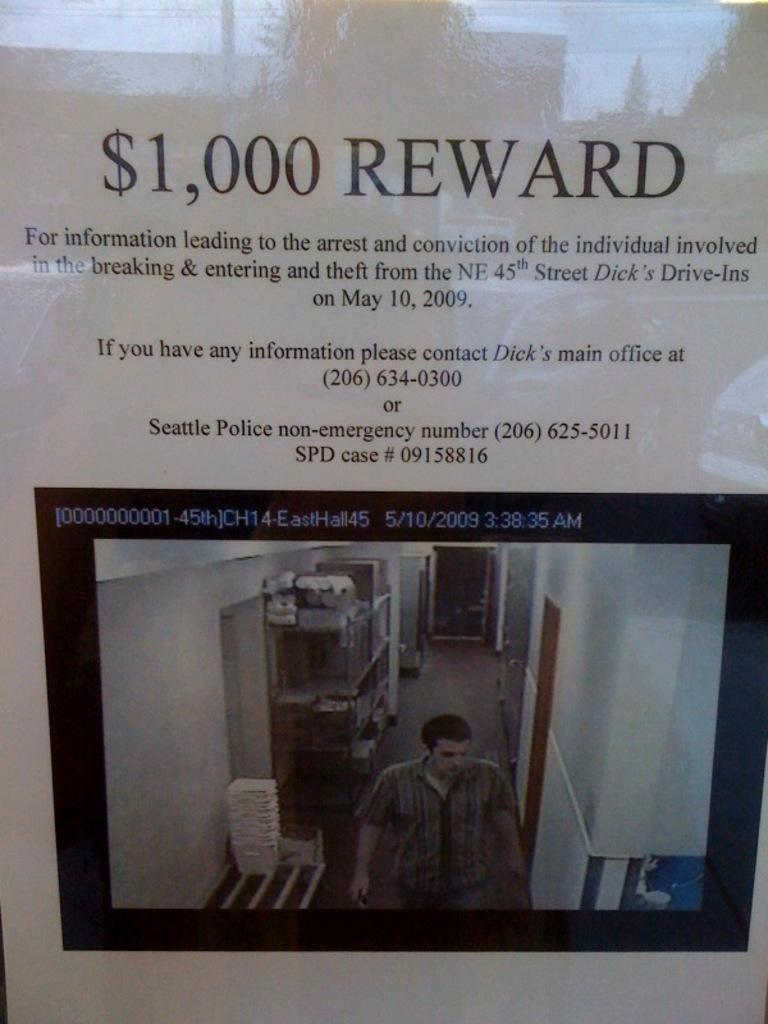What type of visual representation is the image? The image is a poster. What is the main subject depicted in the poster? There is a man depicted on the floor in the poster. What can be seen in the background of the poster? There are walls visible in the poster. What else is present in the poster besides the man and walls? There are objects present in the poster. Is there any text included in the poster? Yes, there is text in the poster. Can you tell me how many jars are placed on the cave floor in the image? There is no cave or jar present in the image; it is a poster featuring a man on the floor with walls and text. 